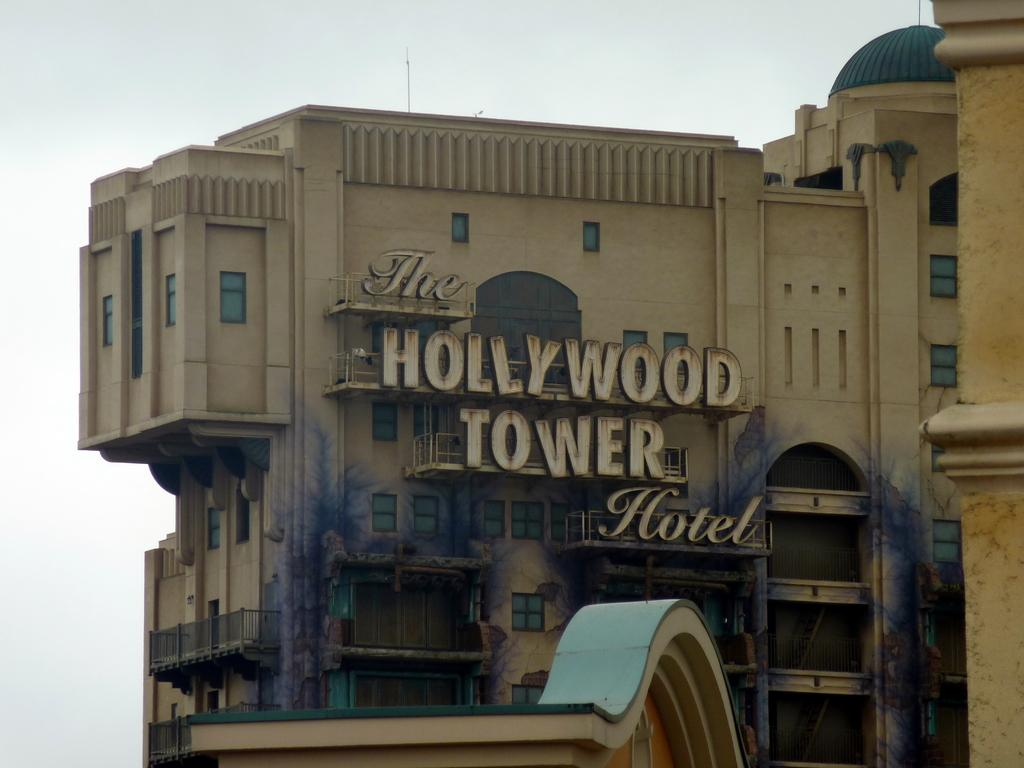<image>
Describe the image concisely. Here is a picture of the Hollywood Tower Hotel. 